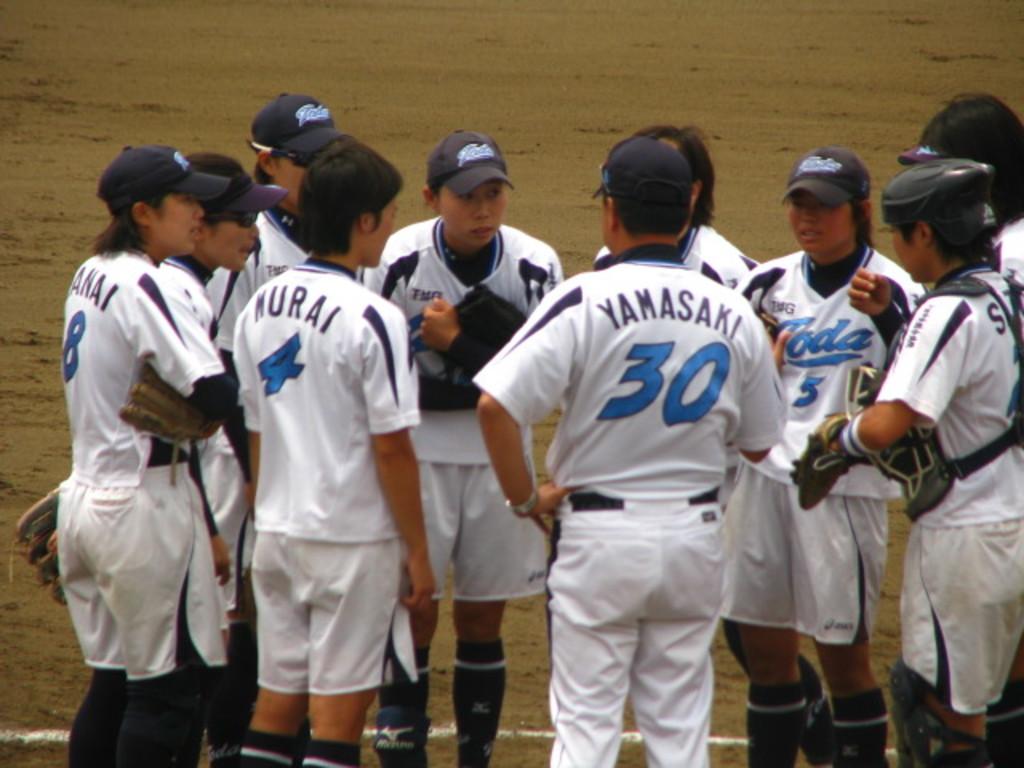What is the last name of player #30?
Keep it short and to the point. Yamasaki. What is the jersey number next to 30?
Offer a very short reply. 4. 